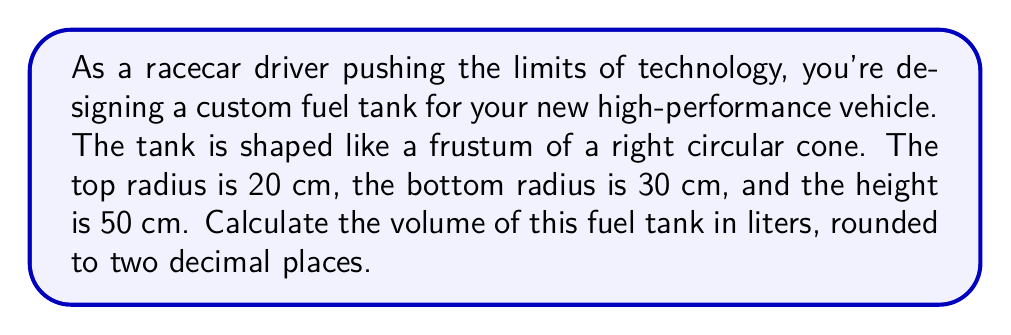Provide a solution to this math problem. To solve this problem, we'll use the formula for the volume of a frustum of a right circular cone and convert the result to liters. Let's break it down step-by-step:

1. The formula for the volume of a frustum is:

   $$V = \frac{1}{3}\pi h(R^2 + r^2 + Rr)$$

   Where:
   $V$ = volume
   $h$ = height
   $R$ = radius of the larger base
   $r$ = radius of the smaller base

2. We're given:
   $h = 50$ cm
   $R = 30$ cm (bottom radius)
   $r = 20$ cm (top radius)

3. Let's substitute these values into the formula:

   $$V = \frac{1}{3}\pi \cdot 50(30^2 + 20^2 + 30 \cdot 20)$$

4. Simplify the expressions inside the parentheses:
   
   $$V = \frac{1}{3}\pi \cdot 50(900 + 400 + 600)$$
   $$V = \frac{1}{3}\pi \cdot 50(1900)$$

5. Multiply:
   
   $$V = \frac{1}{3}\pi \cdot 95000$$

6. Calculate:
   
   $$V \approx 99484.51 \text{ cm}^3$$

7. Convert to liters (1 liter = 1000 cm³):
   
   $$V \approx 99.48 \text{ liters}$$

8. Round to two decimal places:
   
   $$V \approx 99.48 \text{ liters}$$

[asy]
import geometry;

size(200);
real r1 = 30, r2 = 20, h = 50;
real x1 = r1, x2 = r2;
real y1 = 0, y2 = h;

path p = (x1,y1)--(x2,y2)--(0,y2)--(0,y1)--cycle;
fill(p,lightgray);
draw(p);
draw((0,0)--(x1,0),Arrow);
draw((0,h)--(x2,h),Arrow);
draw((0,0)--(0,h),Arrow);

label("30 cm",(-2,0),(x1/2,0),E);
label("20 cm",(-2,h),(x2/2,h),E);
label("50 cm",(0,-2),(0,h/2),S);
[/asy]
Answer: The volume of the fuel tank is approximately 99.48 liters. 